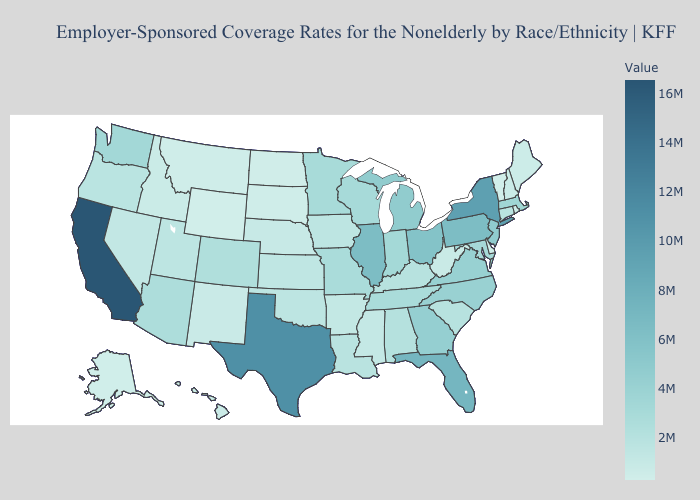Which states have the lowest value in the USA?
Concise answer only. Wyoming. Does the map have missing data?
Quick response, please. No. Which states have the lowest value in the USA?
Answer briefly. Wyoming. Which states have the lowest value in the USA?
Write a very short answer. Wyoming. Which states have the lowest value in the MidWest?
Quick response, please. North Dakota. Among the states that border North Dakota , does South Dakota have the highest value?
Be succinct. No. Does the map have missing data?
Answer briefly. No. 